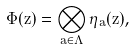<formula> <loc_0><loc_0><loc_500><loc_500>\Phi ( z ) = \bigotimes _ { { a } \in \Lambda } \eta _ { a } ( z ) ,</formula> 